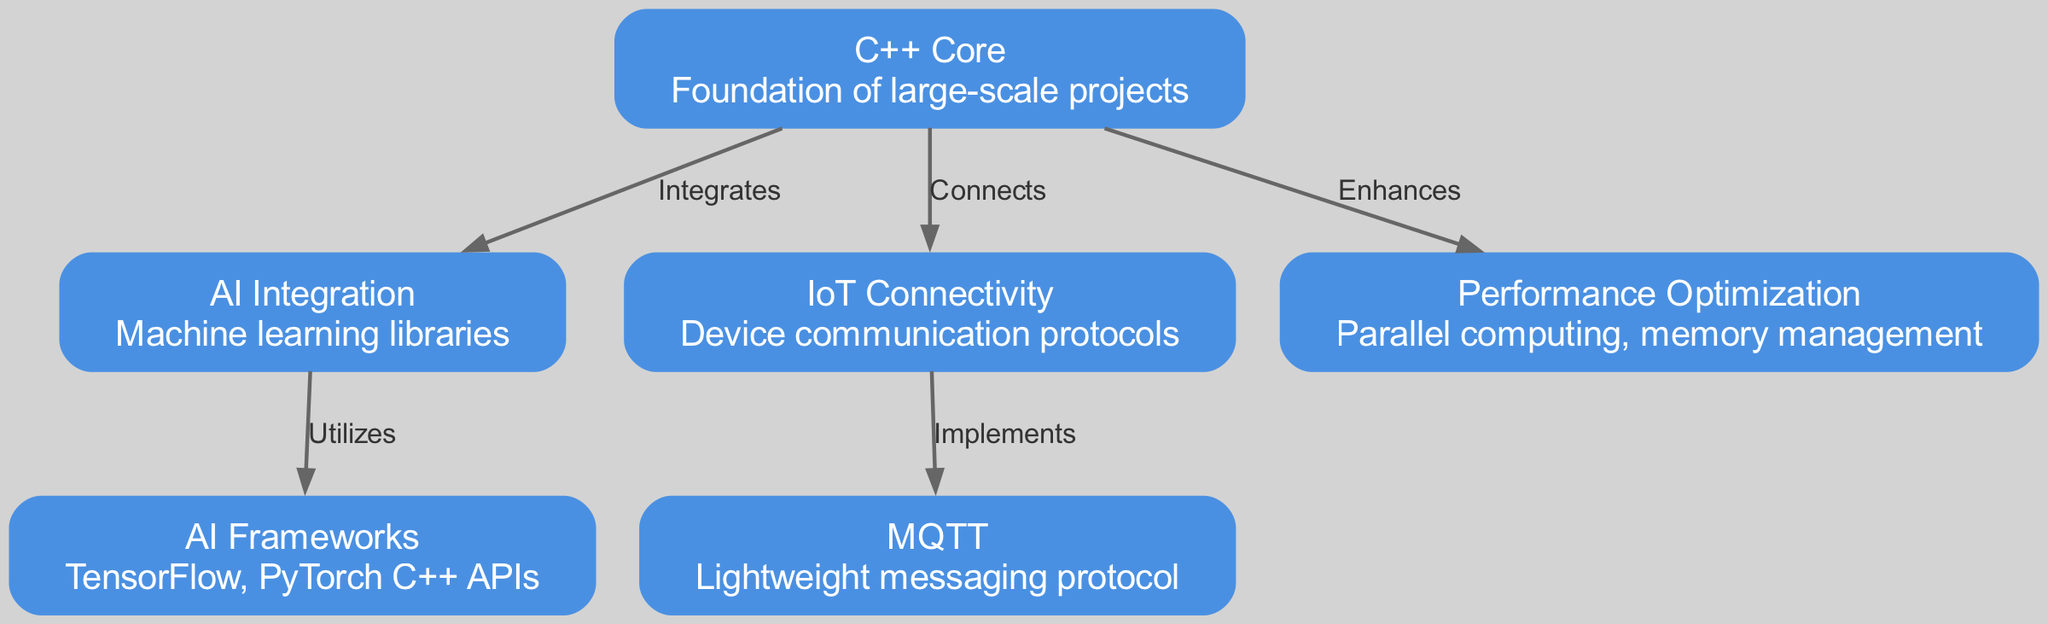What is the central node in the diagram? The central node in the diagram is "C++ Core" as it connects to multiple other nodes, forming the foundation for the integrations shown.
Answer: C++ Core How many nodes are in the diagram? There are a total of six nodes present in the diagram: C++ Core, AI Integration, IoT Connectivity, AI Frameworks, MQTT, and Performance Optimization.
Answer: Six What relationship does "C++ Core" have with "AI Integration"? "C++ Core" has an "Integrates" relationship with "AI Integration," indicating that it serves as a foundational element for integrating AI technologies.
Answer: Integrates Which node implements MQTT? The node that implements MQTT is "IoT Connectivity," as it establishes the communication with devices using this protocol.
Answer: IoT Connectivity How does "AI Integration" utilize frameworks? "AI Integration" utilizes "AI Frameworks," which provide specific libraries such as TensorFlow and PyTorch that facilitate machine learning projects within the C++ environment.
Answer: Utilizes What is the connection label between "cpp" and "optimization"? The connection label between "cpp" and "optimization" is "Enhances," indicating that C++ enhances performance through techniques like parallel computing and memory management.
Answer: Enhances What is the role of "MQTT" in the diagram? "MQTT" plays the role of a messaging protocol within the context of IoT Connectivity, which facilitates lightweight communication between devices.
Answer: Lightweight messaging protocol How many edges are present in the diagram? The diagram contains five edges that represent various relationships and connections between the nodes.
Answer: Five Why is "Performance Optimization" important in C++ projects? "Performance Optimization" is crucial because it focuses on enhancing the capabilities of C++ applications through methods like parallel computing and effective memory management; these are essential for large-scale projects.
Answer: Enhances capabilities What type of technologies does the diagram focus on integrating with C++? The diagram focuses on integrating C++ with emerging technologies such as AI and IoT, showcasing their interrelation in large-scale software projects.
Answer: AI and IoT 